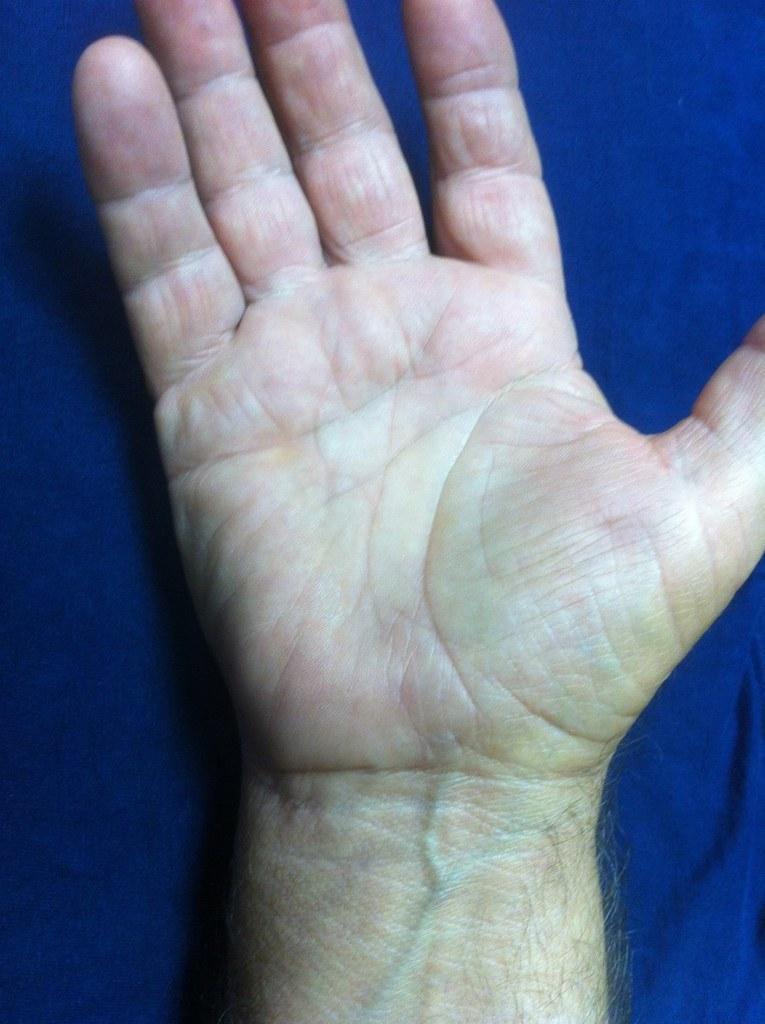Please provide a concise description of this image. In this image there is a hand of the person which is on the blue colour surface. 